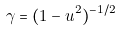<formula> <loc_0><loc_0><loc_500><loc_500>\gamma = ( 1 - u ^ { 2 } ) ^ { - 1 / 2 }</formula> 